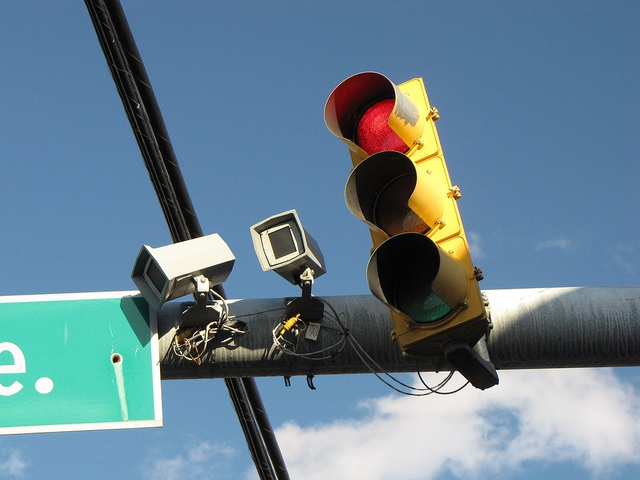Describe the objects in this image and their specific colors. I can see a traffic light in gray, black, khaki, olive, and maroon tones in this image. 